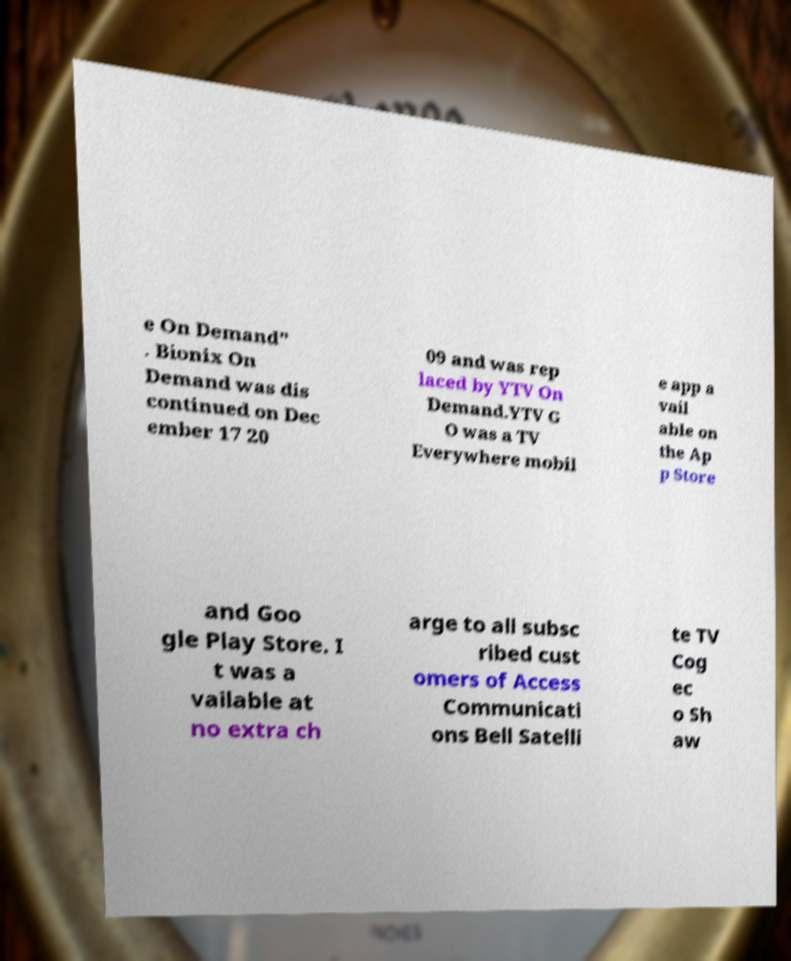For documentation purposes, I need the text within this image transcribed. Could you provide that? e On Demand" . Bionix On Demand was dis continued on Dec ember 17 20 09 and was rep laced by YTV On Demand.YTV G O was a TV Everywhere mobil e app a vail able on the Ap p Store and Goo gle Play Store. I t was a vailable at no extra ch arge to all subsc ribed cust omers of Access Communicati ons Bell Satelli te TV Cog ec o Sh aw 